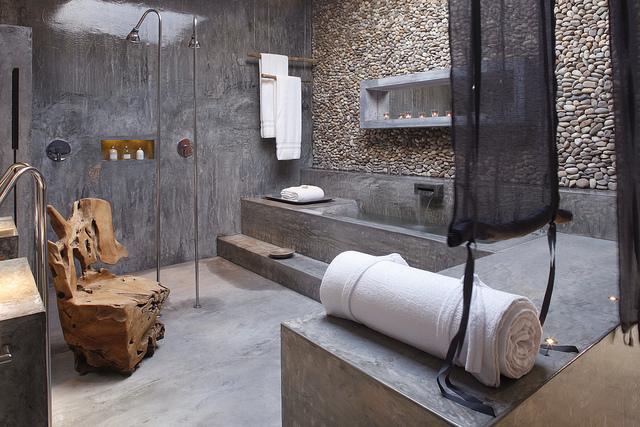Is this a luxury apartment?
Keep it brief. Yes. How many towels are hanging on the wall?
Short answer required. 2. What color are the fixtures?
Keep it brief. Silver. What is the chair made of?
Quick response, please. Wood. 